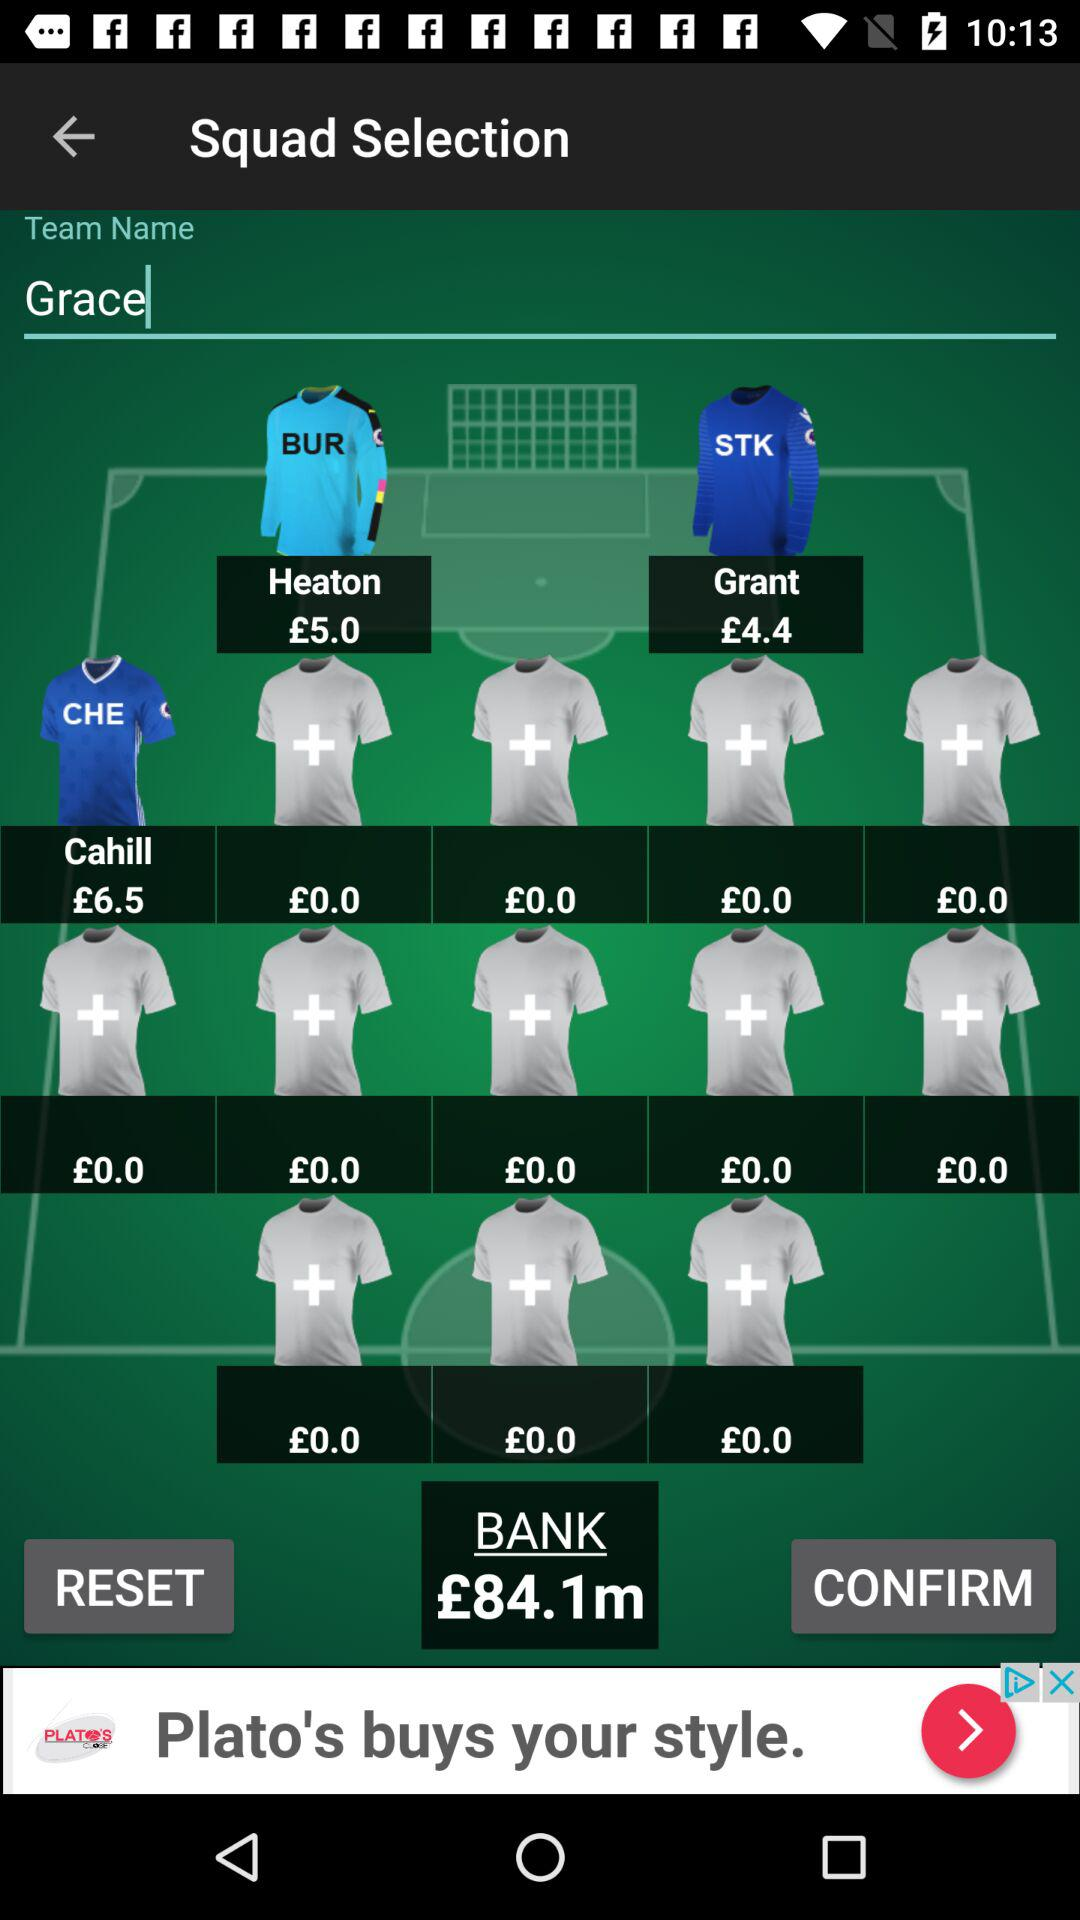How much does Cahill cost? Cahill's cost is £6.5. 